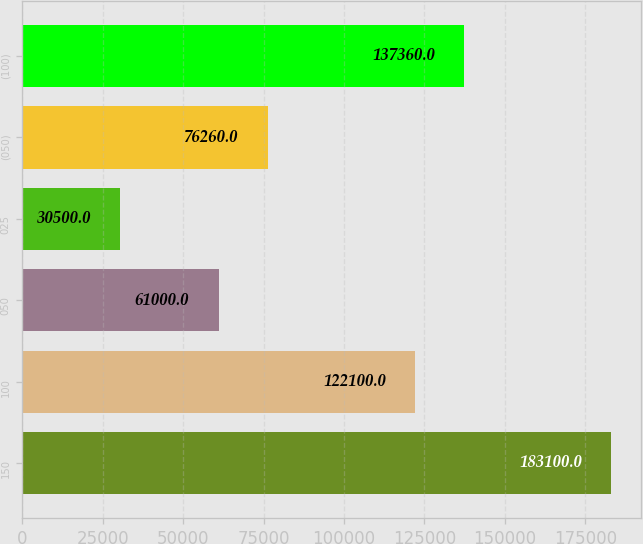Convert chart. <chart><loc_0><loc_0><loc_500><loc_500><bar_chart><fcel>150<fcel>100<fcel>050<fcel>025<fcel>(050)<fcel>(100)<nl><fcel>183100<fcel>122100<fcel>61000<fcel>30500<fcel>76260<fcel>137360<nl></chart> 